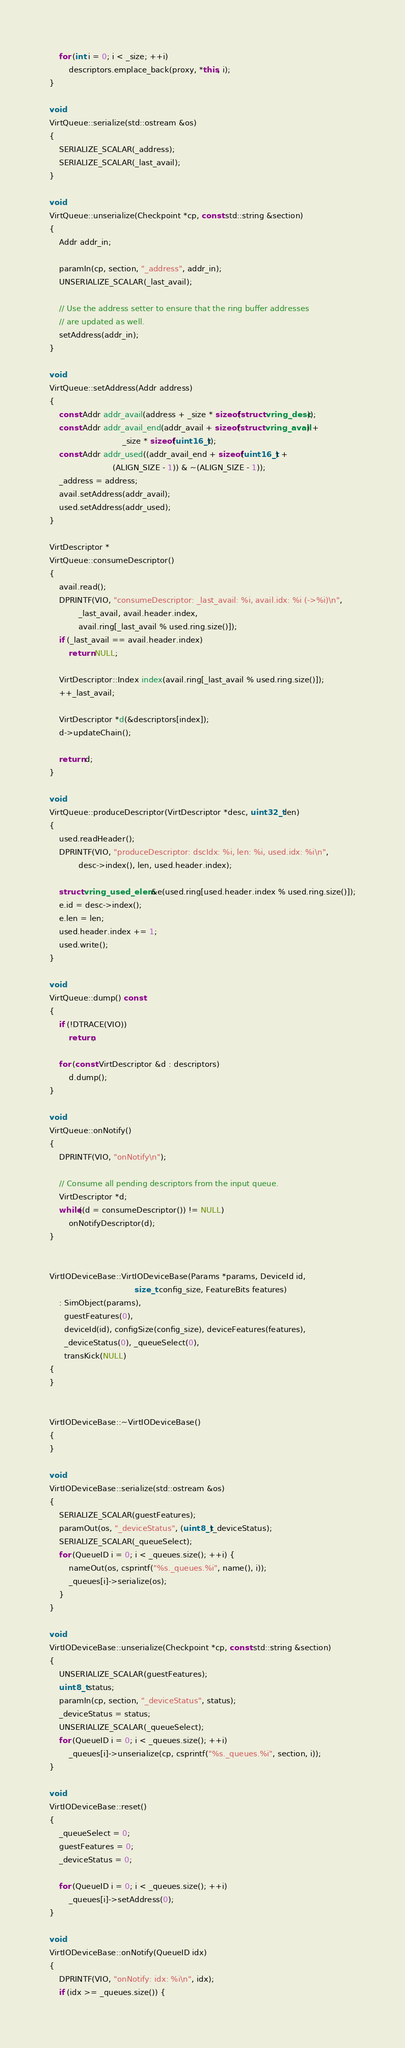Convert code to text. <code><loc_0><loc_0><loc_500><loc_500><_C++_>    for (int i = 0; i < _size; ++i)
        descriptors.emplace_back(proxy, *this, i);
}

void
VirtQueue::serialize(std::ostream &os)
{
    SERIALIZE_SCALAR(_address);
    SERIALIZE_SCALAR(_last_avail);
}

void
VirtQueue::unserialize(Checkpoint *cp, const std::string &section)
{
    Addr addr_in;

    paramIn(cp, section, "_address", addr_in);
    UNSERIALIZE_SCALAR(_last_avail);

    // Use the address setter to ensure that the ring buffer addresses
    // are updated as well.
    setAddress(addr_in);
}

void
VirtQueue::setAddress(Addr address)
{
    const Addr addr_avail(address + _size * sizeof(struct vring_desc));
    const Addr addr_avail_end(addr_avail + sizeof(struct vring_avail) +
                              _size * sizeof(uint16_t));
    const Addr addr_used((addr_avail_end + sizeof(uint16_t) +
                          (ALIGN_SIZE - 1)) & ~(ALIGN_SIZE - 1));
    _address = address;
    avail.setAddress(addr_avail);
    used.setAddress(addr_used);
}

VirtDescriptor *
VirtQueue::consumeDescriptor()
{
    avail.read();
    DPRINTF(VIO, "consumeDescriptor: _last_avail: %i, avail.idx: %i (->%i)\n",
            _last_avail, avail.header.index,
            avail.ring[_last_avail % used.ring.size()]);
    if (_last_avail == avail.header.index)
        return NULL;

    VirtDescriptor::Index index(avail.ring[_last_avail % used.ring.size()]);
    ++_last_avail;

    VirtDescriptor *d(&descriptors[index]);
    d->updateChain();

    return d;
}

void
VirtQueue::produceDescriptor(VirtDescriptor *desc, uint32_t len)
{
    used.readHeader();
    DPRINTF(VIO, "produceDescriptor: dscIdx: %i, len: %i, used.idx: %i\n",
            desc->index(), len, used.header.index);

    struct vring_used_elem &e(used.ring[used.header.index % used.ring.size()]);
    e.id = desc->index();
    e.len = len;
    used.header.index += 1;
    used.write();
}

void
VirtQueue::dump() const
{
    if (!DTRACE(VIO))
        return;

    for (const VirtDescriptor &d : descriptors)
        d.dump();
}

void
VirtQueue::onNotify()
{
    DPRINTF(VIO, "onNotify\n");

    // Consume all pending descriptors from the input queue.
    VirtDescriptor *d;
    while((d = consumeDescriptor()) != NULL)
        onNotifyDescriptor(d);
}


VirtIODeviceBase::VirtIODeviceBase(Params *params, DeviceId id,
                                   size_t config_size, FeatureBits features)
    : SimObject(params),
      guestFeatures(0),
      deviceId(id), configSize(config_size), deviceFeatures(features),
      _deviceStatus(0), _queueSelect(0),
      transKick(NULL)
{
}


VirtIODeviceBase::~VirtIODeviceBase()
{
}

void
VirtIODeviceBase::serialize(std::ostream &os)
{
    SERIALIZE_SCALAR(guestFeatures);
    paramOut(os, "_deviceStatus", (uint8_t)_deviceStatus);
    SERIALIZE_SCALAR(_queueSelect);
    for (QueueID i = 0; i < _queues.size(); ++i) {
        nameOut(os, csprintf("%s._queues.%i", name(), i));
        _queues[i]->serialize(os);
    }
}

void
VirtIODeviceBase::unserialize(Checkpoint *cp, const std::string &section)
{
    UNSERIALIZE_SCALAR(guestFeatures);
    uint8_t status;
    paramIn(cp, section, "_deviceStatus", status);
    _deviceStatus = status;
    UNSERIALIZE_SCALAR(_queueSelect);
    for (QueueID i = 0; i < _queues.size(); ++i)
        _queues[i]->unserialize(cp, csprintf("%s._queues.%i", section, i));
}

void
VirtIODeviceBase::reset()
{
    _queueSelect = 0;
    guestFeatures = 0;
    _deviceStatus = 0;

    for (QueueID i = 0; i < _queues.size(); ++i)
        _queues[i]->setAddress(0);
}

void
VirtIODeviceBase::onNotify(QueueID idx)
{
    DPRINTF(VIO, "onNotify: idx: %i\n", idx);
    if (idx >= _queues.size()) {</code> 